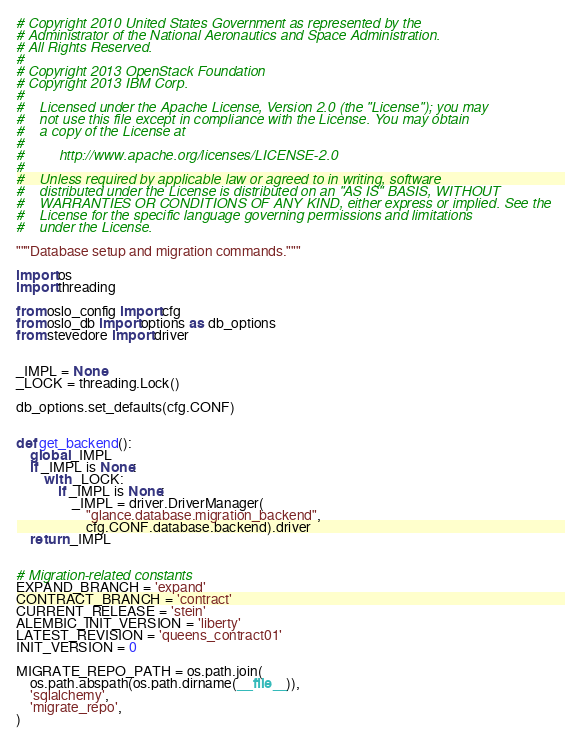Convert code to text. <code><loc_0><loc_0><loc_500><loc_500><_Python_># Copyright 2010 United States Government as represented by the
# Administrator of the National Aeronautics and Space Administration.
# All Rights Reserved.
#
# Copyright 2013 OpenStack Foundation
# Copyright 2013 IBM Corp.
#
#    Licensed under the Apache License, Version 2.0 (the "License"); you may
#    not use this file except in compliance with the License. You may obtain
#    a copy of the License at
#
#         http://www.apache.org/licenses/LICENSE-2.0
#
#    Unless required by applicable law or agreed to in writing, software
#    distributed under the License is distributed on an "AS IS" BASIS, WITHOUT
#    WARRANTIES OR CONDITIONS OF ANY KIND, either express or implied. See the
#    License for the specific language governing permissions and limitations
#    under the License.

"""Database setup and migration commands."""

import os
import threading

from oslo_config import cfg
from oslo_db import options as db_options
from stevedore import driver


_IMPL = None
_LOCK = threading.Lock()

db_options.set_defaults(cfg.CONF)


def get_backend():
    global _IMPL
    if _IMPL is None:
        with _LOCK:
            if _IMPL is None:
                _IMPL = driver.DriverManager(
                    "glance.database.migration_backend",
                    cfg.CONF.database.backend).driver
    return _IMPL


# Migration-related constants
EXPAND_BRANCH = 'expand'
CONTRACT_BRANCH = 'contract'
CURRENT_RELEASE = 'stein'
ALEMBIC_INIT_VERSION = 'liberty'
LATEST_REVISION = 'queens_contract01'
INIT_VERSION = 0

MIGRATE_REPO_PATH = os.path.join(
    os.path.abspath(os.path.dirname(__file__)),
    'sqlalchemy',
    'migrate_repo',
)
</code> 